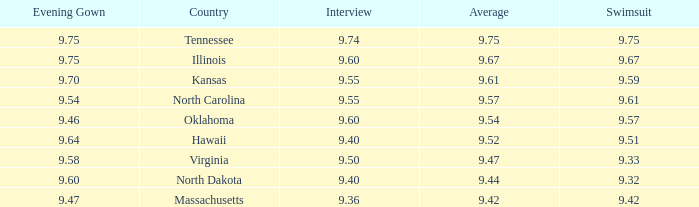What was the interview score for Hawaii? 9.4. 